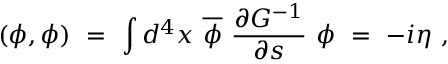Convert formula to latex. <formula><loc_0><loc_0><loc_500><loc_500>( \phi , \phi ) \ = \ \int d ^ { 4 } x \ \overline { \phi } \ \frac { \partial G ^ { - 1 } } { \partial s } \ \phi \ = \ - i \eta \ ,</formula> 